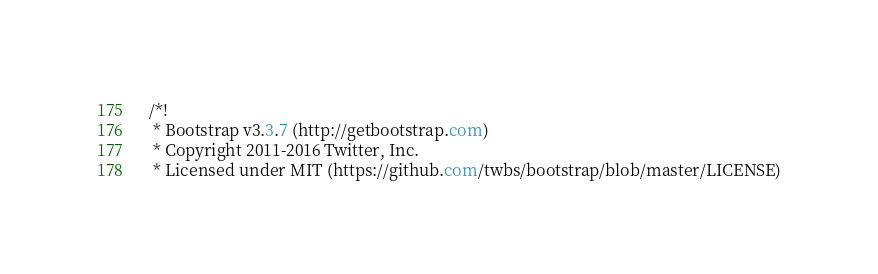Convert code to text. <code><loc_0><loc_0><loc_500><loc_500><_CSS_>/*!
 * Bootstrap v3.3.7 (http://getbootstrap.com)
 * Copyright 2011-2016 Twitter, Inc.
 * Licensed under MIT (https://github.com/twbs/bootstrap/blob/master/LICENSE)</code> 